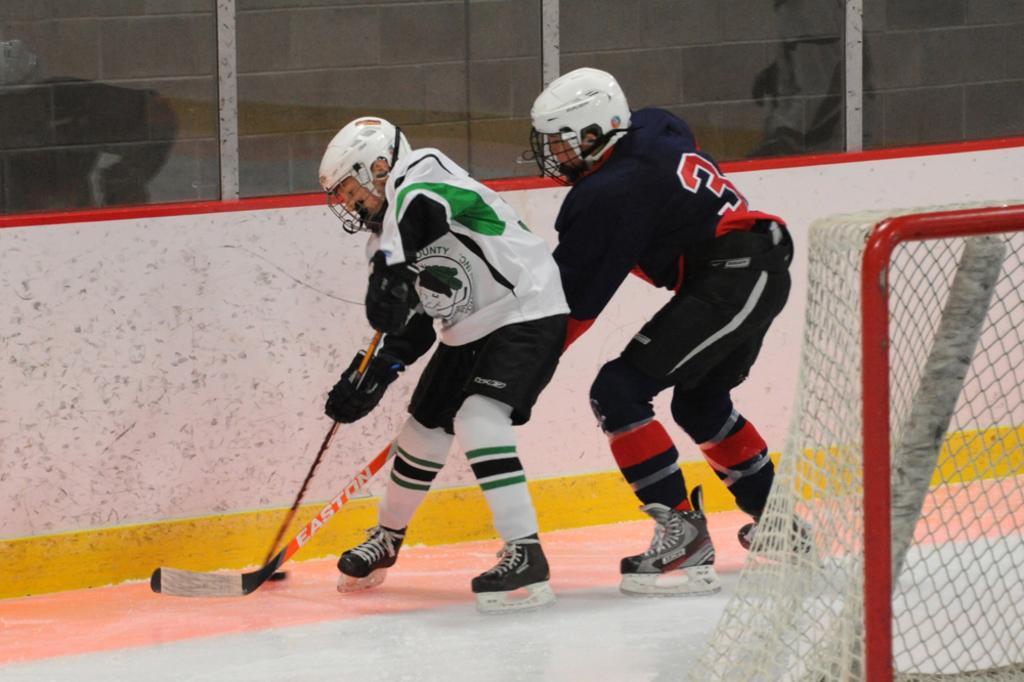Can you describe this image briefly? In the foreground I can see two persons are playing a hockey on the ground and a goal net. In the background I can see fence and glass windows. This image is taken may be during a day. 